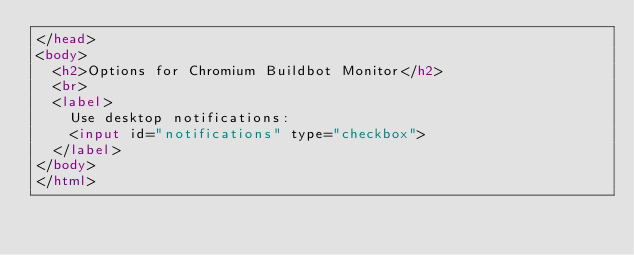Convert code to text. <code><loc_0><loc_0><loc_500><loc_500><_HTML_></head>
<body>
  <h2>Options for Chromium Buildbot Monitor</h2>
  <br>
  <label>
    Use desktop notifications:
    <input id="notifications" type="checkbox">
  </label>
</body>
</html>
</code> 